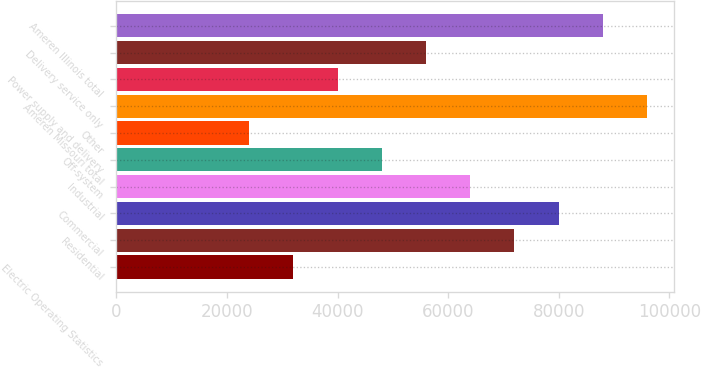Convert chart to OTSL. <chart><loc_0><loc_0><loc_500><loc_500><bar_chart><fcel>Electric Operating Statistics<fcel>Residential<fcel>Commercial<fcel>Industrial<fcel>Off-system<fcel>Other<fcel>Ameren Missouri total<fcel>Power supply and delivery<fcel>Delivery service only<fcel>Ameren Illinois total<nl><fcel>32000<fcel>71962.5<fcel>79955<fcel>63970<fcel>47985<fcel>24007.5<fcel>95940<fcel>39992.5<fcel>55977.5<fcel>87947.5<nl></chart> 